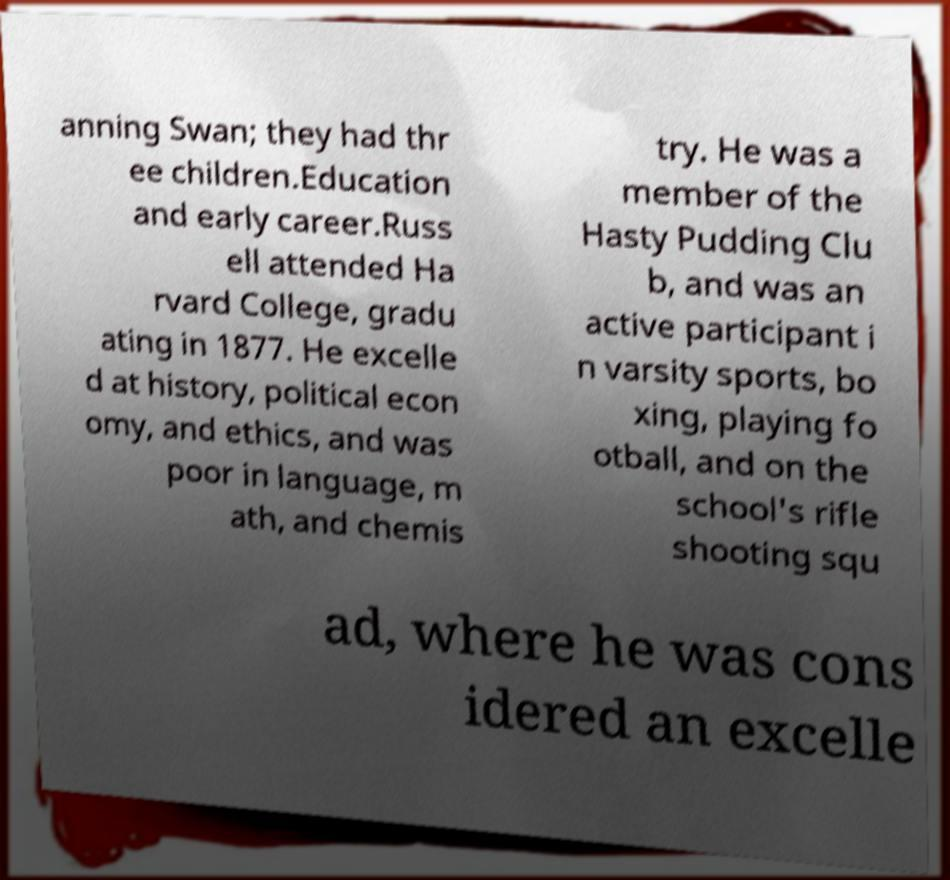Please read and relay the text visible in this image. What does it say? anning Swan; they had thr ee children.Education and early career.Russ ell attended Ha rvard College, gradu ating in 1877. He excelle d at history, political econ omy, and ethics, and was poor in language, m ath, and chemis try. He was a member of the Hasty Pudding Clu b, and was an active participant i n varsity sports, bo xing, playing fo otball, and on the school's rifle shooting squ ad, where he was cons idered an excelle 